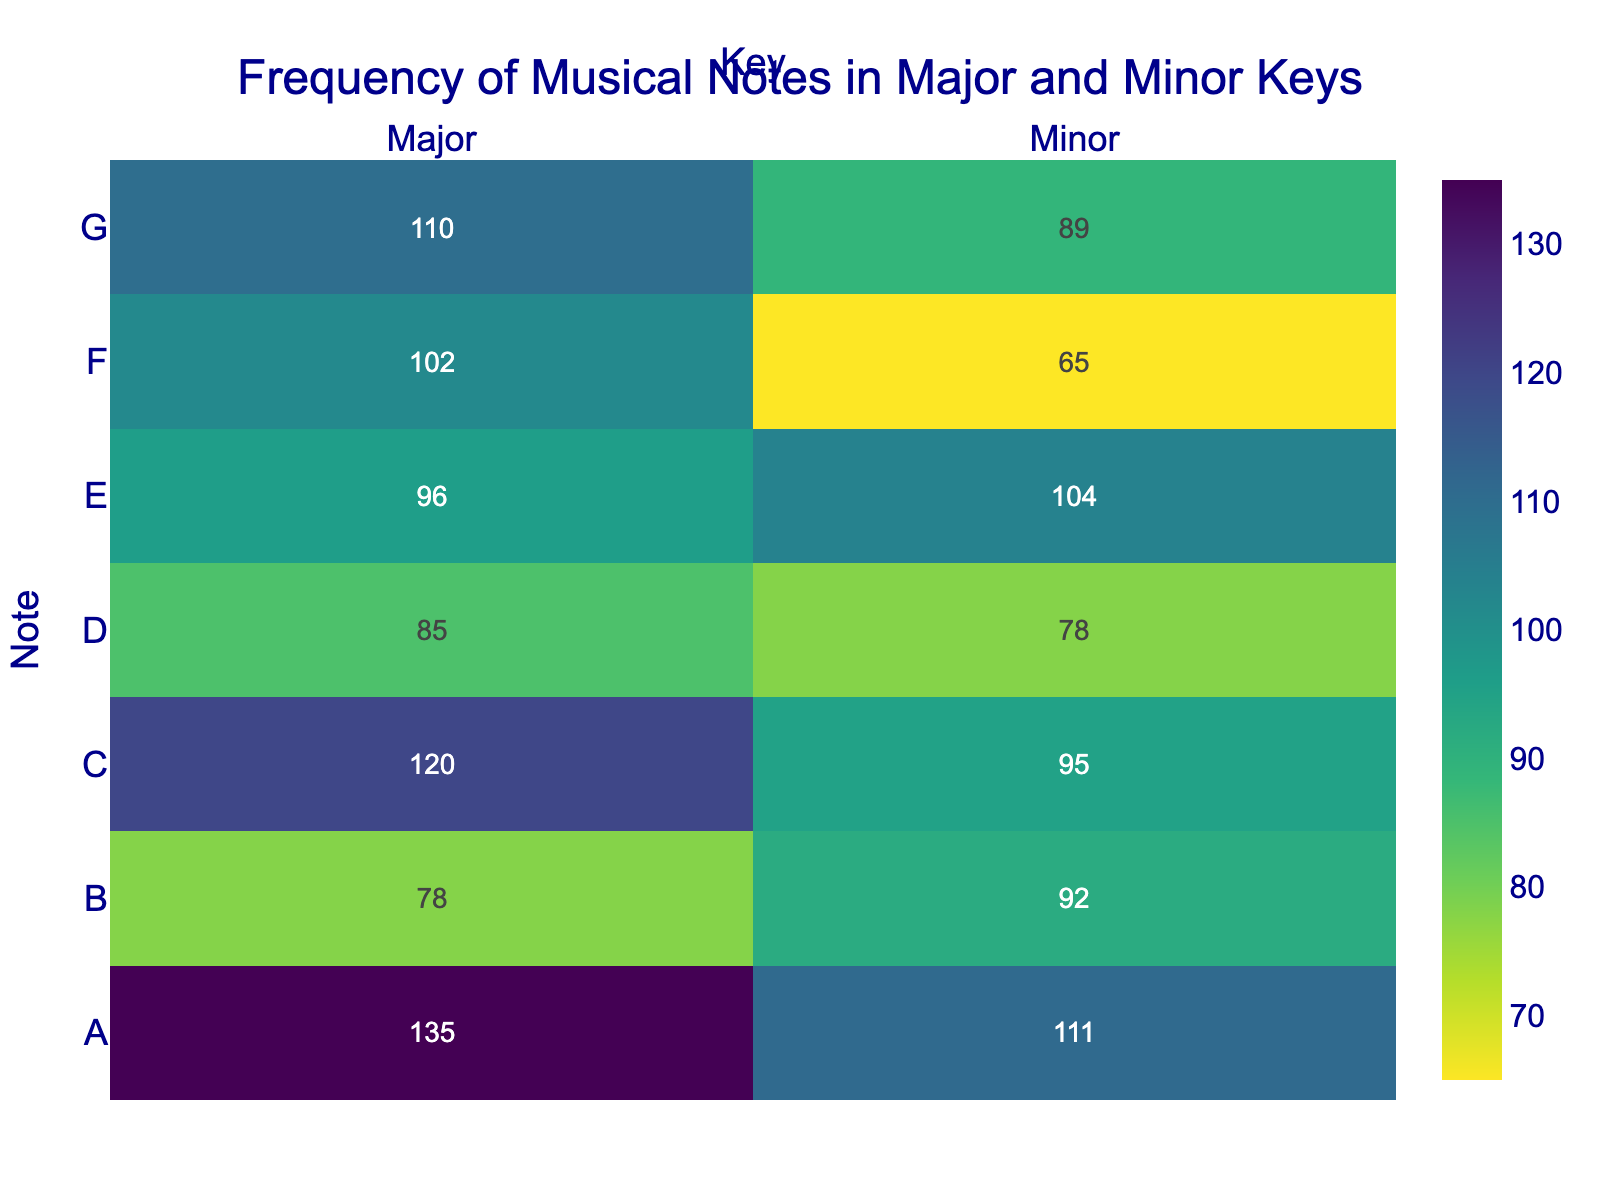What is the title of the heatmap? The title is displayed at the top center of the heatmap in a large, dark blue font. It states the main topic and context of the heatmap.
Answer: Frequency of Musical Notes in Major and Minor Keys Which musical note has the highest frequency in the Major key? Look at the row where the Note is 'A' in the column for the Major key. This cell has the highest value among all Major key notes.
Answer: A How many more times is the note E used in Minor key compared to Major key? Find the difference between the values in the 'E' row for Major (96) and Minor (104) keys. Perform the subtraction: 104 - 96.
Answer: 8 Which note has the lowest frequency in the Minor key? Look at the column for the Minor key and identify the smallest value. This occurs at the Note 'F'.
Answer: F What is the sum of the frequencies of note D in both Major and Minor keys? Find the values for the note D in both columns, Major (85) and Minor (78). Add them: 85 + 78.
Answer: 163 Compare the frequency of note G between Major and Minor keys. Which one is higher, and by how much? Look at the values for note G in both key columns: Major (110) and Minor (89). Subtract the Minor value from the Major value.
Answer: Major is higher by 21 What is the difference in frequencies of note B between Major and Minor keys? Subtract the frequency of note B in the Minor key (92) from its frequency in the Major key (78).
Answer: 14 Identify the most frequent note in the Minor key. Look at the column for the Minor key and find the largest value. This occurs at the Note 'A'.
Answer: A Calculate the average frequency of the note C in both Major and Minor keys combined. Find the values for note C in both key columns: Major (120) and Minor (95). Add them and then divide by 2: (120 + 95) / 2.
Answer: 107.5 Which key has a higher total frequency of musical notes, Major or Minor? Sum all the values in the Major key column and the Minor key column separately, then compare the sums.
Answer: Major 